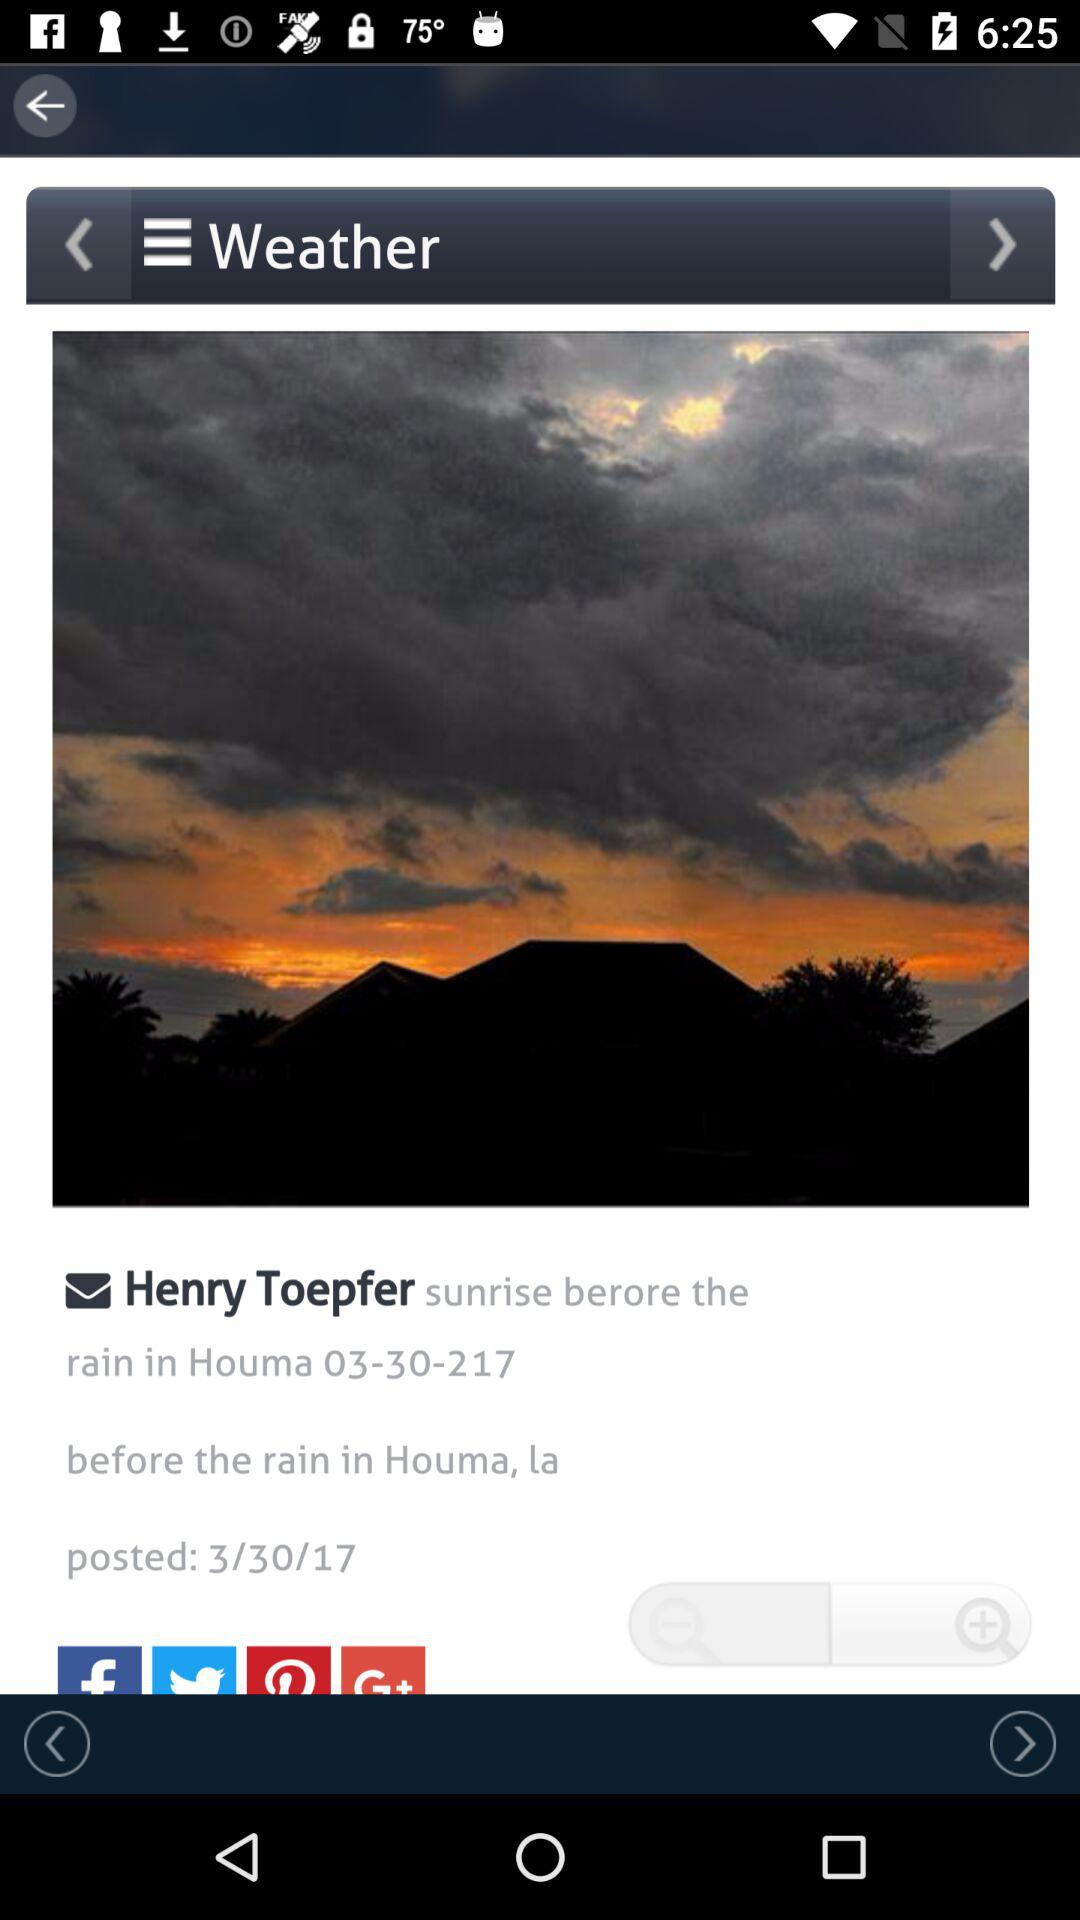When was the post posted? The post was posted on March 30, 2017. 